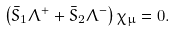<formula> <loc_0><loc_0><loc_500><loc_500>\left ( \bar { S } _ { 1 } \Lambda ^ { + } + \bar { S } _ { 2 } \Lambda ^ { - } \right ) \chi _ { \mu } = 0 .</formula> 